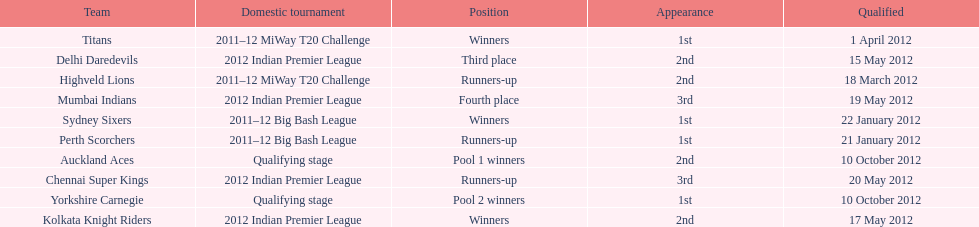Which team debuted in the same competition as the perth scorchers? Sydney Sixers. 